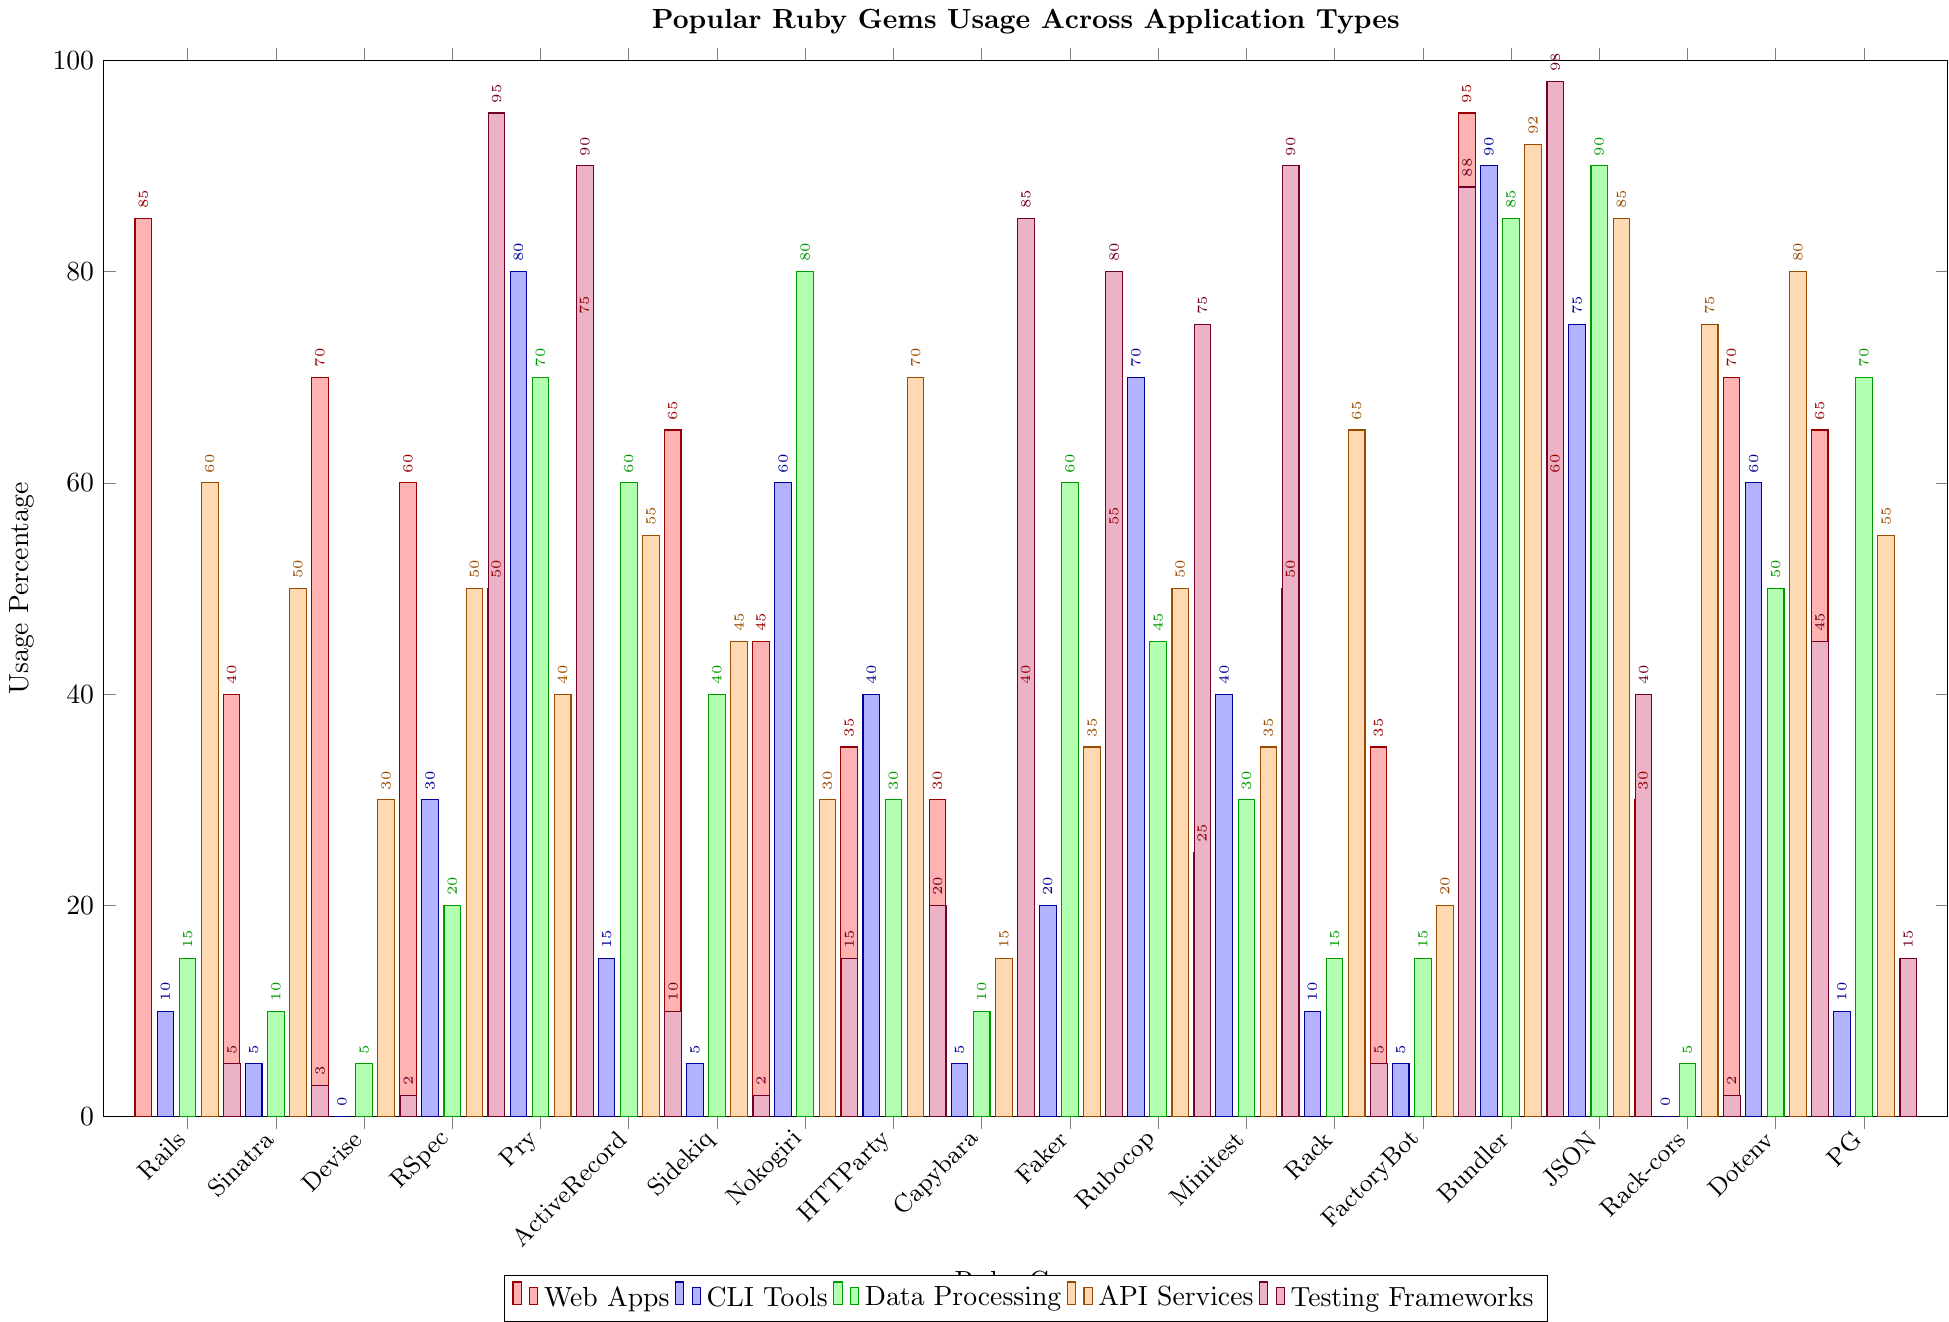Which gem has the highest usage percentage in web apps? By visually inspecting the y-axis values for the "Web Apps" category (red bars), we can see that "Bundler" has the tallest red bar, which corresponds to the highest value in this category.
Answer: Bundler Which gem is most frequently used for testing frameworks? By looking at the "Testing Frameworks" category (purple bars), we see that "Bundler" has the tallest purple bar, indicating it has the highest usage for testing frameworks.
Answer: Bundler Which gem shows zero usage in both CLI tools and data processing? By checking the green (CLI Tools) and blue (Data Processing) bars for each gem, we find "Devise" has both the green and blue bars set to zero.
Answer: Devise Compare the usage of JSON in data processing and API services. Which one is higher? To compare the "Data Processing" (blue bar) with the "API Services" (orange bar) for "JSON," we see that the blue bar is taller than the orange bar. Therefore, JSON is used more in data processing than in API services.
Answer: Data Processing Which two gems have equal usage in data processing? By looking at the heights of the blue bars and checking for equal heights, we see that "Capybara" and "Rack" both have the same height on the blue bars, indicating equal usage.
Answer: Capybara and Rack Calculate the total usage of Pry across all application types. Summing the values from each category: 50 (Web Apps) + 80 (CLI Tools) + 70 (Data Processing) + 40 (API Services) + 90 (Testing Frameworks). This totals: 50 + 80 + 70 + 40 + 90 = 330.
Answer: 330 Which gem is most versatile, being used across the most application types? Checking to see which gem has non-zero values in the most categories, we notice "Pry" has significant usage across all five categories, making it highly versatile.
Answer: Pry What is the difference in usage for API Services between Bundler and Rubocop? From the visual, Bundler's orange bar is at 92, and Rubocop's orange bar is at 50. The difference is 92 - 50 = 42.
Answer: 42 Which gem has the lowest usage in API services? By looking for the shortest orange bar, we find that "FactoryBot" has the lowest usage, indicated by a height of 20.
Answer: FactoryBot 